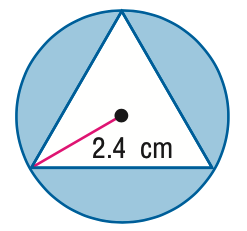Answer the mathemtical geometry problem and directly provide the correct option letter.
Question: Find the area of the shaded region. Assume that all polygons that appear to be regular are regular. Round to the nearest tenth.
Choices: A: 10.6 B: 15.2 C: 15.6 D: 18.1 A 